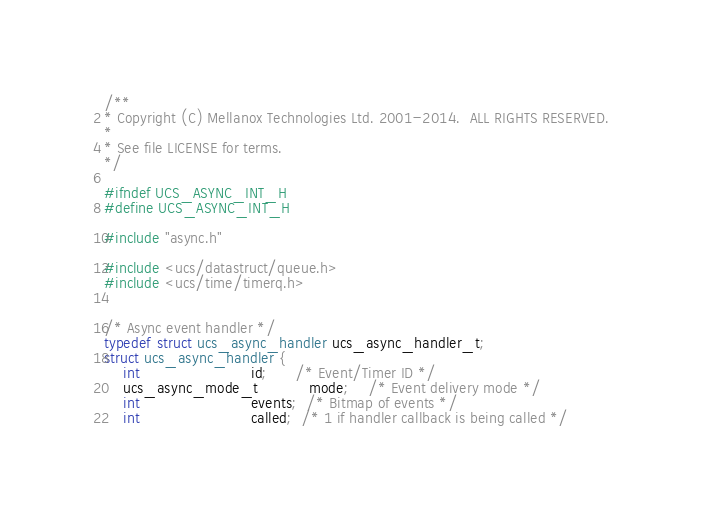Convert code to text. <code><loc_0><loc_0><loc_500><loc_500><_C_>/**
* Copyright (C) Mellanox Technologies Ltd. 2001-2014.  ALL RIGHTS RESERVED.
*
* See file LICENSE for terms.
*/

#ifndef UCS_ASYNC_INT_H
#define UCS_ASYNC_INT_H

#include "async.h"

#include <ucs/datastruct/queue.h>
#include <ucs/time/timerq.h>


/* Async event handler */
typedef struct ucs_async_handler ucs_async_handler_t;
struct ucs_async_handler {
    int                        id;      /* Event/Timer ID */
    ucs_async_mode_t           mode;    /* Event delivery mode */
    int                        events;  /* Bitmap of events */
    int                        called;  /* 1 if handler callback is being called */</code> 